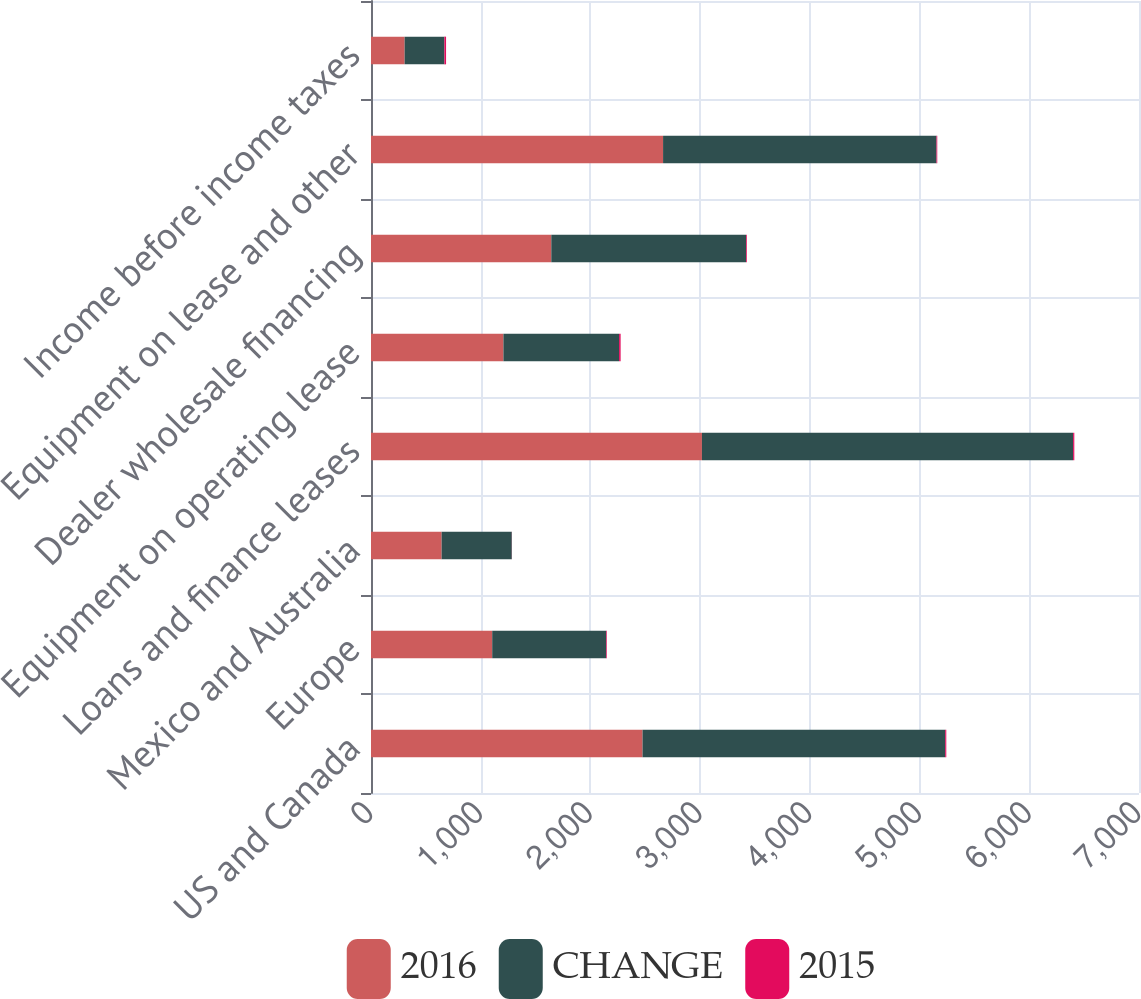Convert chart to OTSL. <chart><loc_0><loc_0><loc_500><loc_500><stacked_bar_chart><ecel><fcel>US and Canada<fcel>Europe<fcel>Mexico and Australia<fcel>Loans and finance leases<fcel>Equipment on operating lease<fcel>Dealer wholesale financing<fcel>Equipment on lease and other<fcel>Income before income taxes<nl><fcel>2016<fcel>2474.9<fcel>1104.8<fcel>643.7<fcel>3016.4<fcel>1207<fcel>1643.4<fcel>2662.1<fcel>306.5<nl><fcel>CHANGE<fcel>2758.7<fcel>1039<fcel>639.5<fcel>3383<fcel>1054.2<fcel>1775.2<fcel>2492.2<fcel>362.6<nl><fcel>2015<fcel>10<fcel>6<fcel>1<fcel>11<fcel>14<fcel>7<fcel>7<fcel>15<nl></chart> 